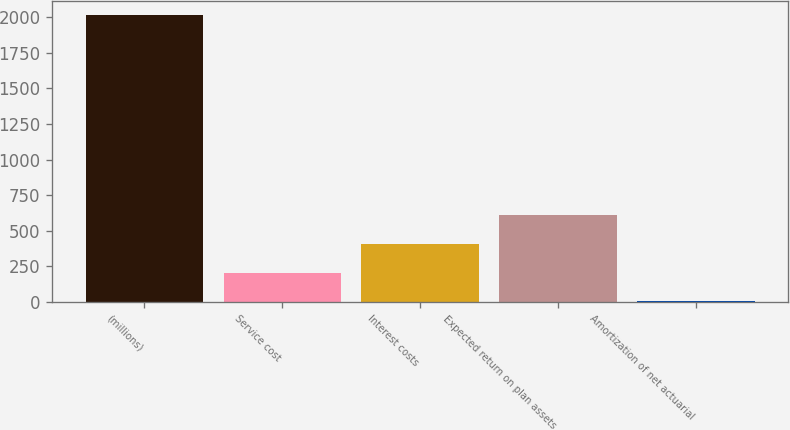Convert chart to OTSL. <chart><loc_0><loc_0><loc_500><loc_500><bar_chart><fcel>(millions)<fcel>Service cost<fcel>Interest costs<fcel>Expected return on plan assets<fcel>Amortization of net actuarial<nl><fcel>2013<fcel>206.34<fcel>407.08<fcel>607.82<fcel>5.6<nl></chart> 